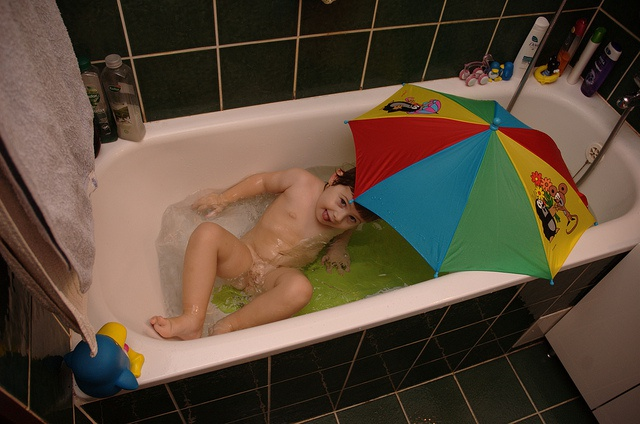Describe the objects in this image and their specific colors. I can see umbrella in brown, teal, darkgreen, maroon, and olive tones, people in brown, salmon, and maroon tones, bottle in brown, black, maroon, and gray tones, bottle in brown, black, maroon, and gray tones, and bottle in brown, black, and maroon tones in this image. 